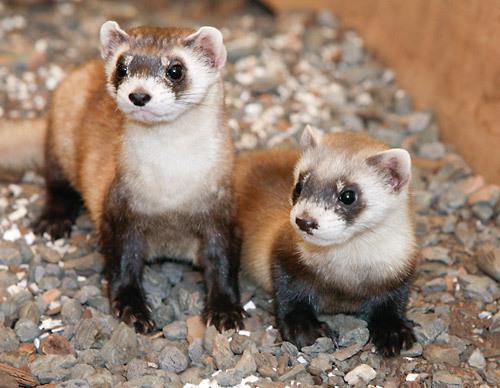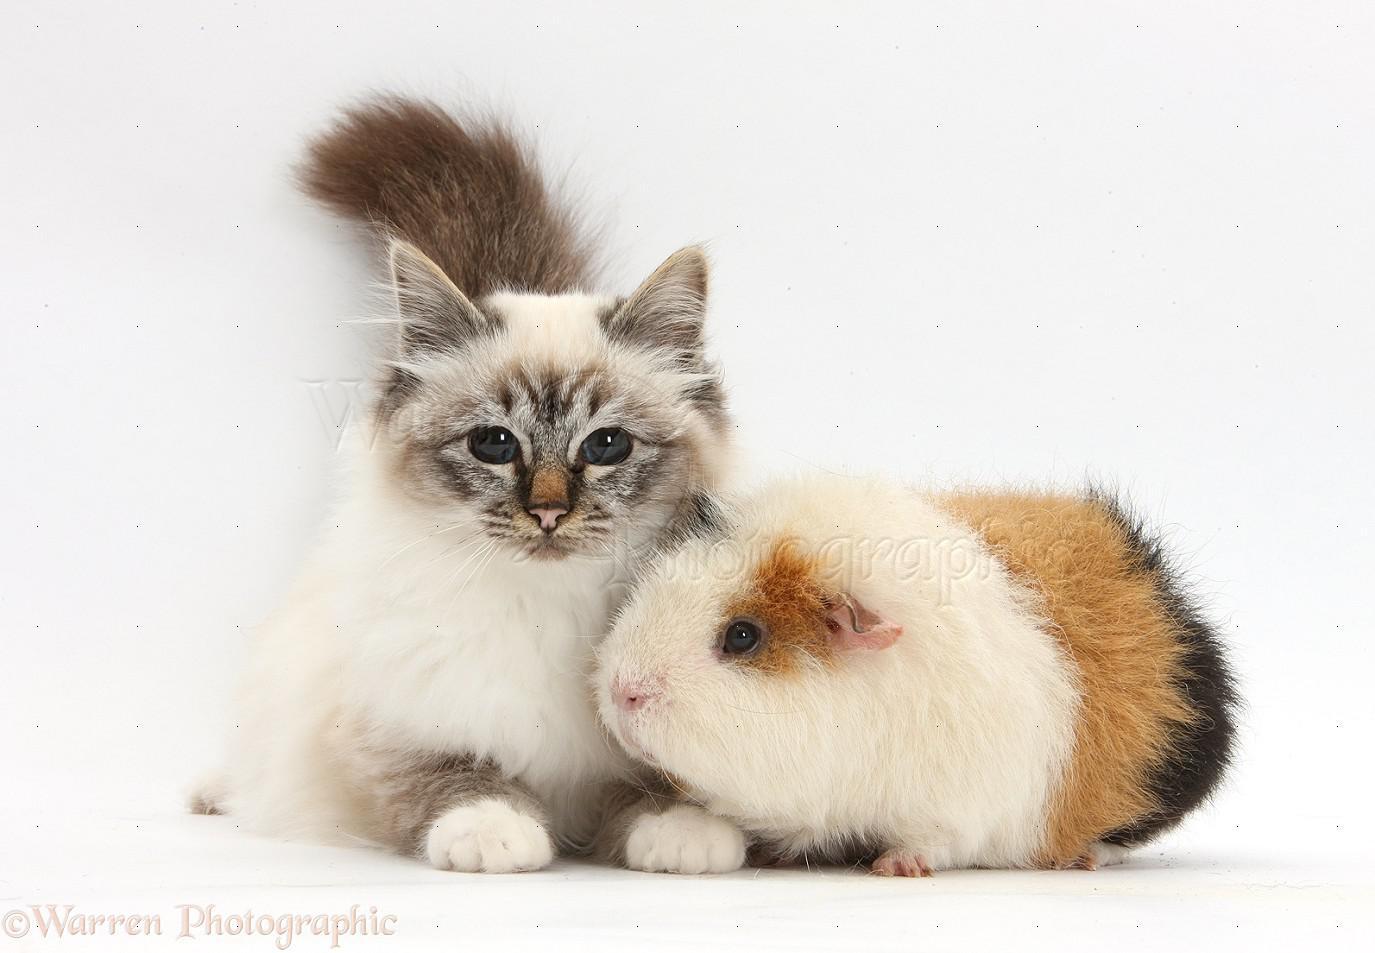The first image is the image on the left, the second image is the image on the right. Considering the images on both sides, is "Each image shows a guinea pig posed next to a different kind of pet, and one image shows a cat sleeping with its head against an awake guinea pig." valid? Answer yes or no. No. The first image is the image on the left, the second image is the image on the right. Considering the images on both sides, is "There are three species of animals." valid? Answer yes or no. Yes. 